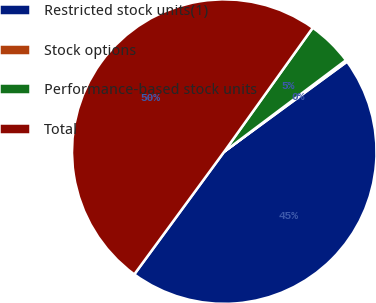Convert chart. <chart><loc_0><loc_0><loc_500><loc_500><pie_chart><fcel>Restricted stock units(1)<fcel>Stock options<fcel>Performance-based stock units<fcel>Total<nl><fcel>45.13%<fcel>0.19%<fcel>4.87%<fcel>49.81%<nl></chart> 